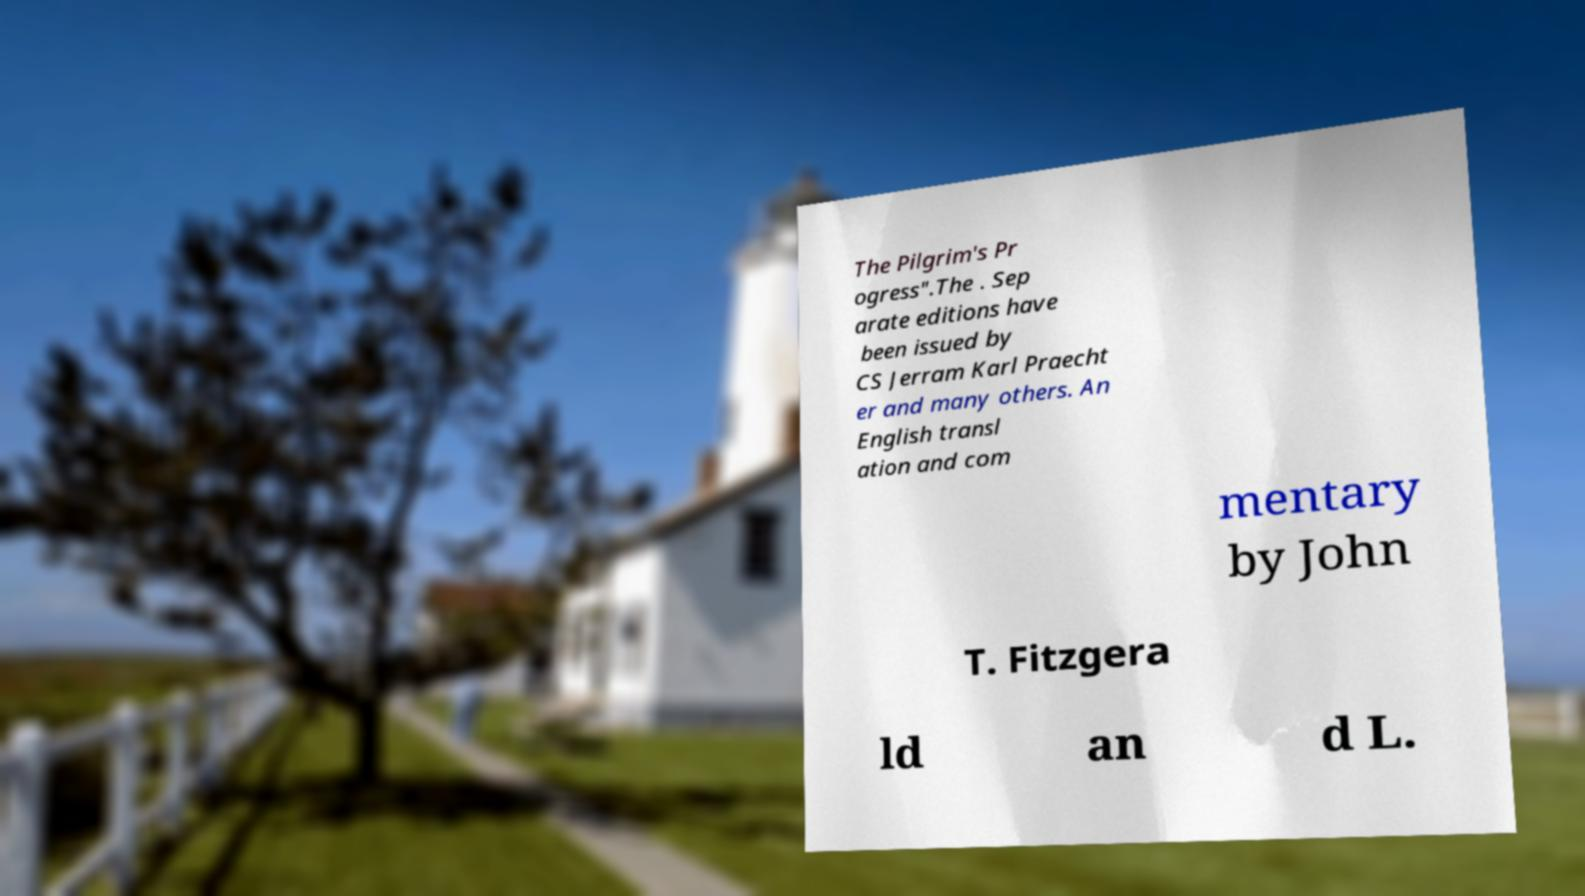Could you extract and type out the text from this image? The Pilgrim's Pr ogress".The . Sep arate editions have been issued by CS Jerram Karl Praecht er and many others. An English transl ation and com mentary by John T. Fitzgera ld an d L. 